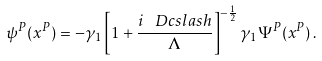<formula> <loc_0><loc_0><loc_500><loc_500>\psi ^ { P } ( x ^ { P } ) = - \gamma _ { 1 } \left [ 1 + \frac { i \, \ D c s l a s h } { \Lambda } \right ] ^ { - \frac { 1 } { 2 } } \gamma _ { 1 } \Psi ^ { P } ( x ^ { P } ) \, .</formula> 